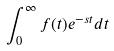<formula> <loc_0><loc_0><loc_500><loc_500>\int _ { 0 } ^ { \infty } f ( t ) e ^ { - s t } d t</formula> 